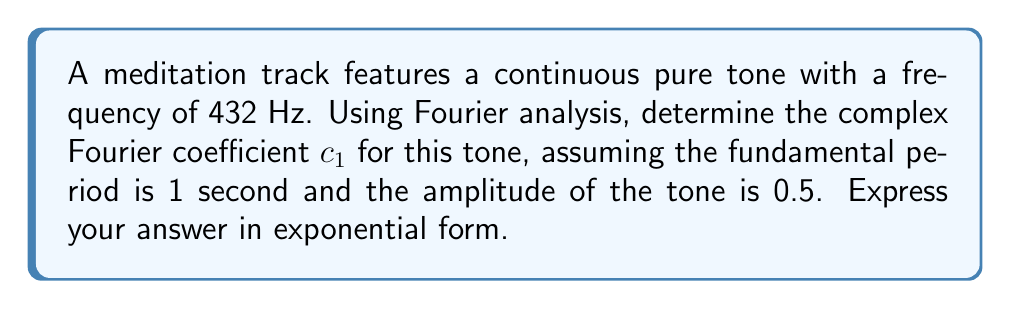Can you solve this math problem? Let's approach this step-by-step:

1) The general form of a complex Fourier coefficient is:

   $$c_n = \frac{1}{T} \int_0^T f(t) e^{-i2\pi nt/T} dt$$

   where $T$ is the fundamental period, $n$ is the harmonic number, and $f(t)$ is the function.

2) In this case:
   - $T = 1$ second (given)
   - $n = 1$ (we're asked for $c_1$)
   - $f(t) = 0.5 \cos(2\pi \cdot 432t)$ (amplitude 0.5, frequency 432 Hz)

3) Substituting these into the formula:

   $$c_1 = \int_0^1 0.5 \cos(2\pi \cdot 432t) e^{-i2\pi t} dt$$

4) Using Euler's formula, we can write:

   $$\cos(2\pi \cdot 432t) = \frac{1}{2}(e^{i2\pi \cdot 432t} + e^{-i2\pi \cdot 432t})$$

5) Substituting this in:

   $$c_1 = \frac{1}{4} \int_0^1 (e^{i2\pi \cdot 432t} + e^{-i2\pi \cdot 432t}) e^{-i2\pi t} dt$$

6) Simplifying the exponents:

   $$c_1 = \frac{1}{4} \int_0^1 (e^{i2\pi \cdot 431t} + e^{-i2\pi \cdot 433t}) dt$$

7) Integrating:

   $$c_1 = \frac{1}{4} [\frac{e^{i2\pi \cdot 431t}}{i2\pi \cdot 431} - \frac{e^{-i2\pi \cdot 433t}}{i2\pi \cdot 433}]_0^1$$

8) Evaluating at the limits:

   $$c_1 = \frac{1}{4} (\frac{e^{i2\pi \cdot 431} - 1}{i2\pi \cdot 431} - \frac{e^{-i2\pi \cdot 433} - 1}{i2\pi \cdot 433})$$

9) Simplifying (note that $e^{i2\pi k} = 1$ for any integer $k$):

   $$c_1 = \frac{1}{4} (\frac{1 - 1}{i2\pi \cdot 431} - \frac{1 - 1}{i2\pi \cdot 433}) = 0$$

Therefore, the complex Fourier coefficient $c_1$ is zero.
Answer: $c_1 = 0$ 